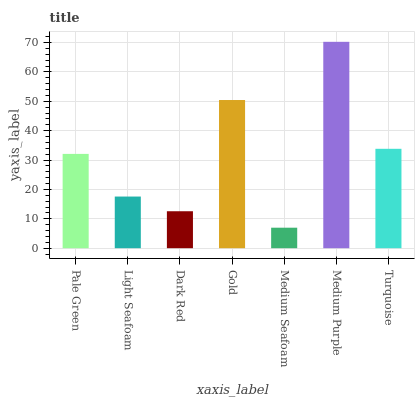Is Light Seafoam the minimum?
Answer yes or no. No. Is Light Seafoam the maximum?
Answer yes or no. No. Is Pale Green greater than Light Seafoam?
Answer yes or no. Yes. Is Light Seafoam less than Pale Green?
Answer yes or no. Yes. Is Light Seafoam greater than Pale Green?
Answer yes or no. No. Is Pale Green less than Light Seafoam?
Answer yes or no. No. Is Pale Green the high median?
Answer yes or no. Yes. Is Pale Green the low median?
Answer yes or no. Yes. Is Medium Seafoam the high median?
Answer yes or no. No. Is Medium Seafoam the low median?
Answer yes or no. No. 